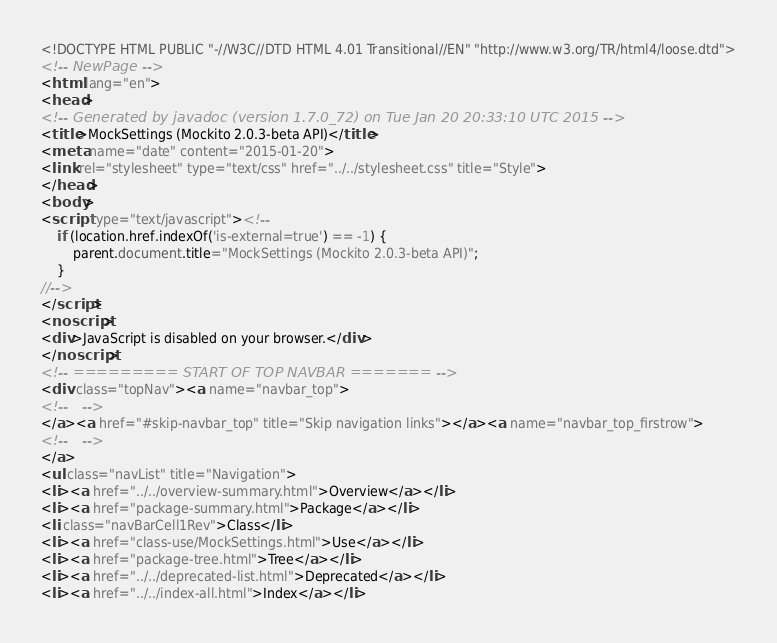<code> <loc_0><loc_0><loc_500><loc_500><_HTML_><!DOCTYPE HTML PUBLIC "-//W3C//DTD HTML 4.01 Transitional//EN" "http://www.w3.org/TR/html4/loose.dtd">
<!-- NewPage -->
<html lang="en">
<head>
<!-- Generated by javadoc (version 1.7.0_72) on Tue Jan 20 20:33:10 UTC 2015 -->
<title>MockSettings (Mockito 2.0.3-beta API)</title>
<meta name="date" content="2015-01-20">
<link rel="stylesheet" type="text/css" href="../../stylesheet.css" title="Style">
</head>
<body>
<script type="text/javascript"><!--
    if (location.href.indexOf('is-external=true') == -1) {
        parent.document.title="MockSettings (Mockito 2.0.3-beta API)";
    }
//-->
</script>
<noscript>
<div>JavaScript is disabled on your browser.</div>
</noscript>
<!-- ========= START OF TOP NAVBAR ======= -->
<div class="topNav"><a name="navbar_top">
<!--   -->
</a><a href="#skip-navbar_top" title="Skip navigation links"></a><a name="navbar_top_firstrow">
<!--   -->
</a>
<ul class="navList" title="Navigation">
<li><a href="../../overview-summary.html">Overview</a></li>
<li><a href="package-summary.html">Package</a></li>
<li class="navBarCell1Rev">Class</li>
<li><a href="class-use/MockSettings.html">Use</a></li>
<li><a href="package-tree.html">Tree</a></li>
<li><a href="../../deprecated-list.html">Deprecated</a></li>
<li><a href="../../index-all.html">Index</a></li></code> 